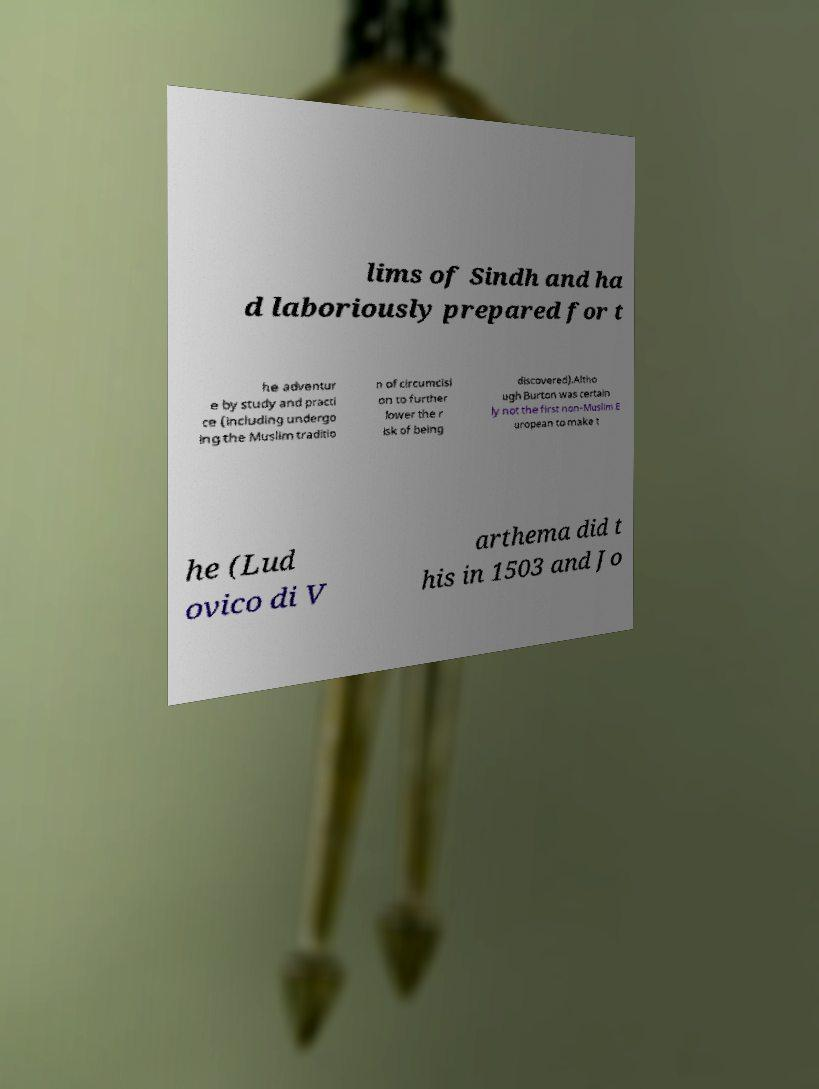There's text embedded in this image that I need extracted. Can you transcribe it verbatim? lims of Sindh and ha d laboriously prepared for t he adventur e by study and practi ce (including undergo ing the Muslim traditio n of circumcisi on to further lower the r isk of being discovered).Altho ugh Burton was certain ly not the first non-Muslim E uropean to make t he (Lud ovico di V arthema did t his in 1503 and Jo 